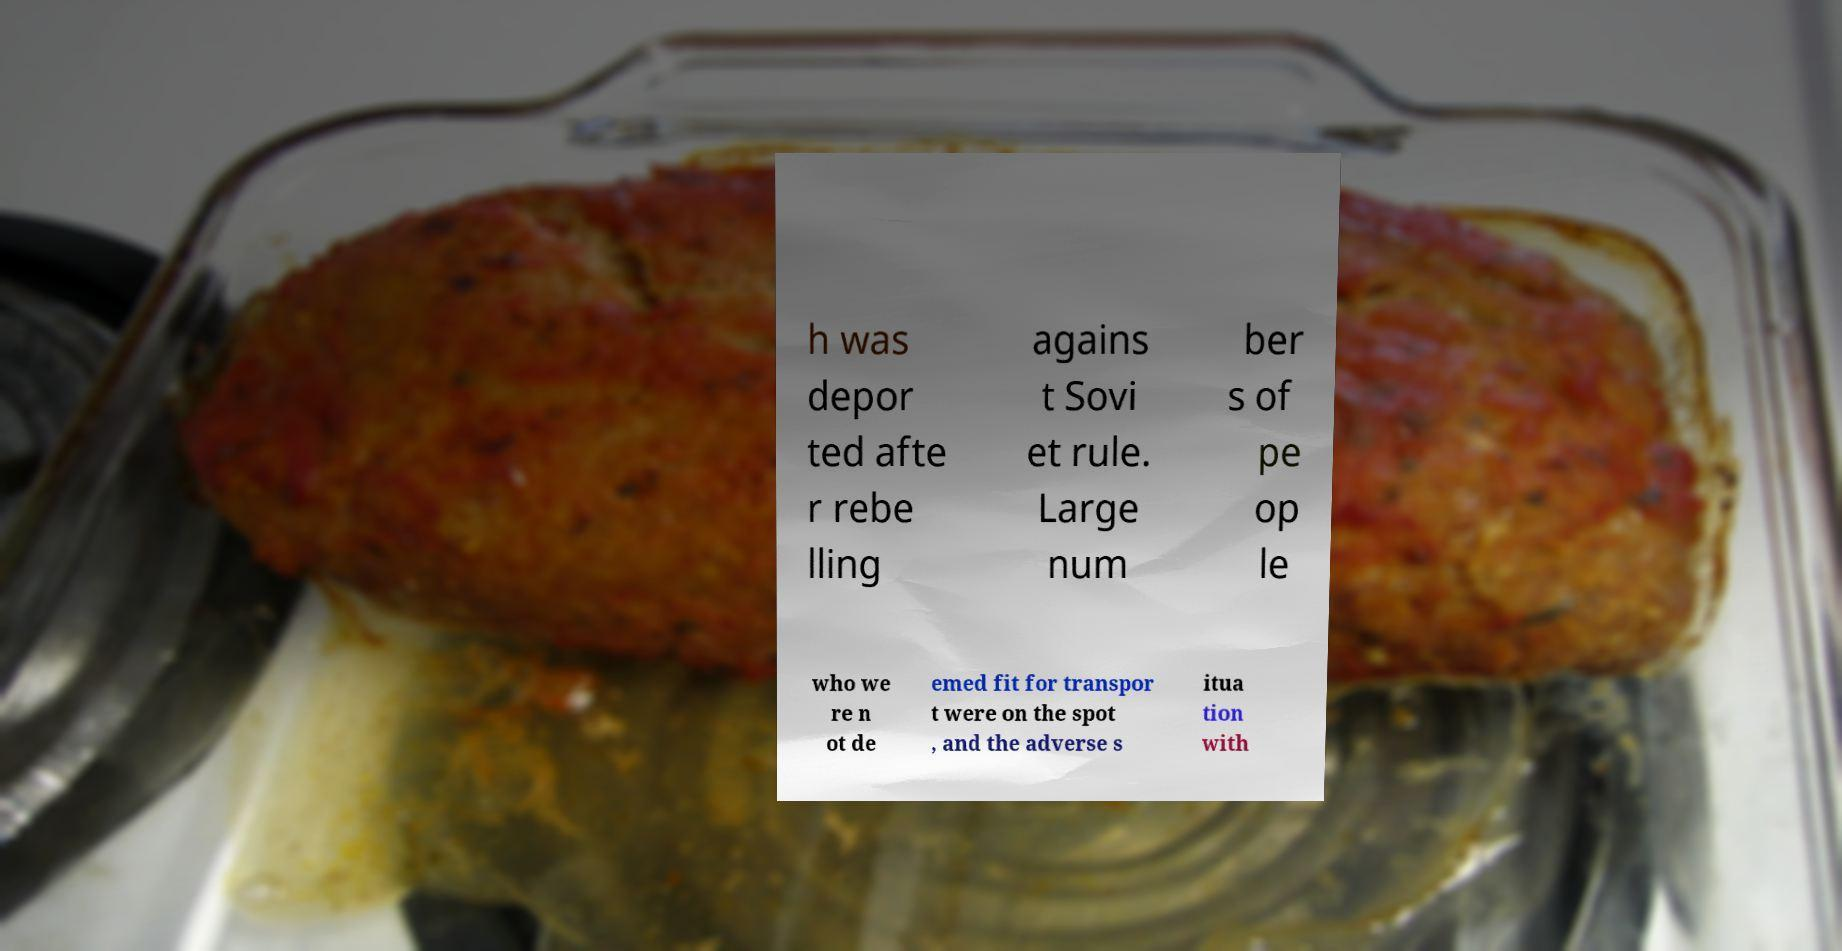Please identify and transcribe the text found in this image. h was depor ted afte r rebe lling agains t Sovi et rule. Large num ber s of pe op le who we re n ot de emed fit for transpor t were on the spot , and the adverse s itua tion with 